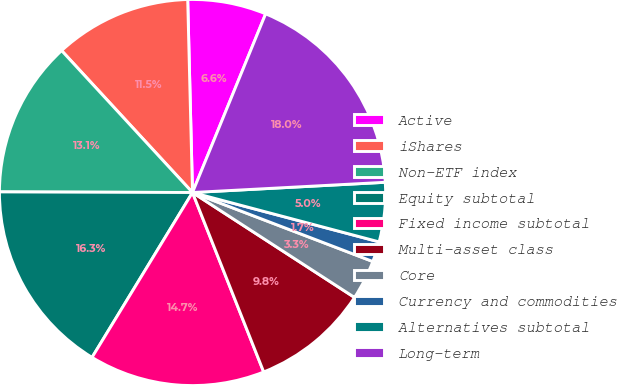Convert chart to OTSL. <chart><loc_0><loc_0><loc_500><loc_500><pie_chart><fcel>Active<fcel>iShares<fcel>Non-ETF index<fcel>Equity subtotal<fcel>Fixed income subtotal<fcel>Multi-asset class<fcel>Core<fcel>Currency and commodities<fcel>Alternatives subtotal<fcel>Long-term<nl><fcel>6.58%<fcel>11.46%<fcel>13.09%<fcel>16.34%<fcel>14.72%<fcel>9.84%<fcel>3.33%<fcel>1.7%<fcel>4.96%<fcel>17.97%<nl></chart> 